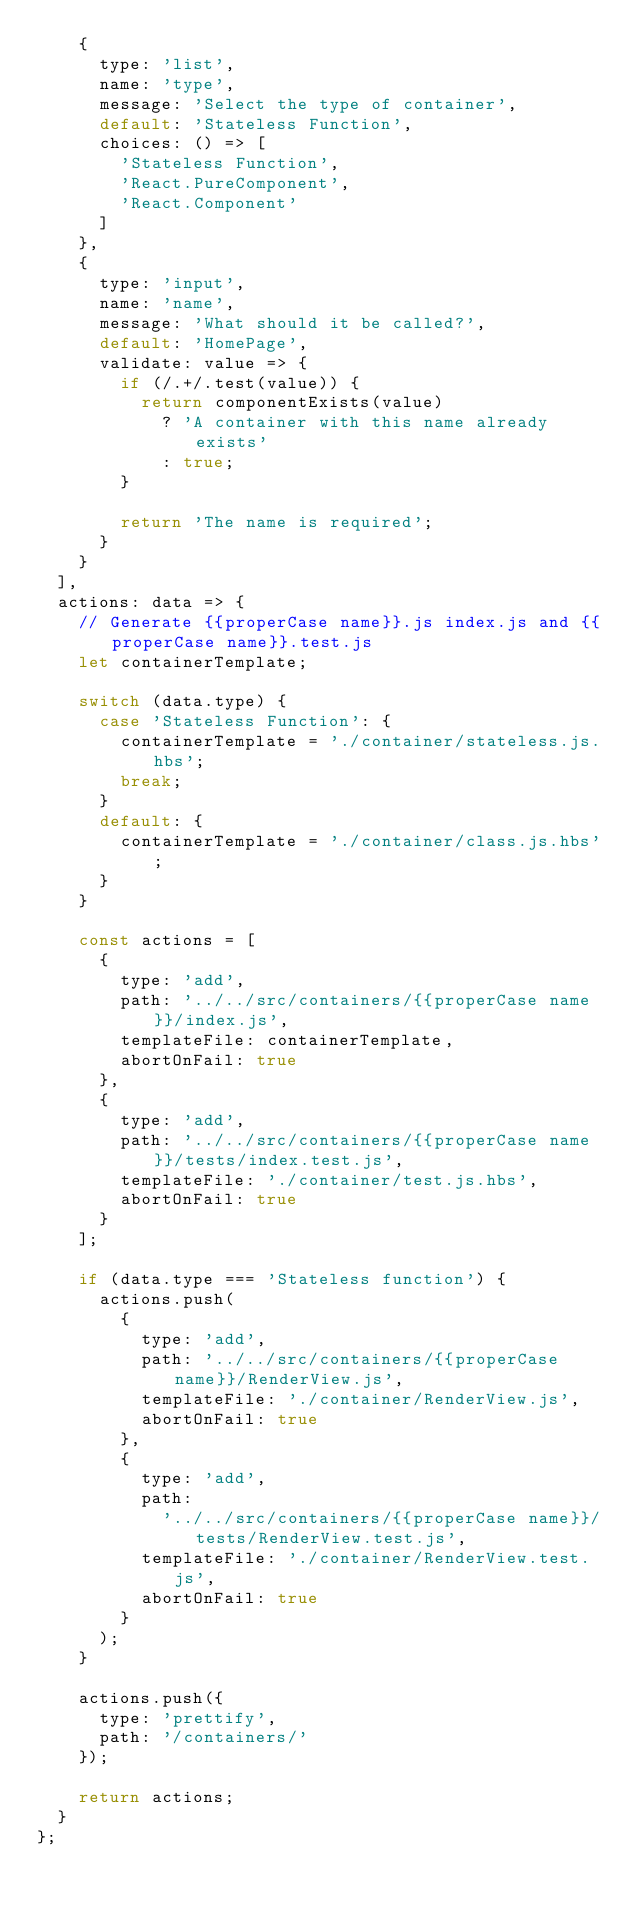Convert code to text. <code><loc_0><loc_0><loc_500><loc_500><_JavaScript_>    {
      type: 'list',
      name: 'type',
      message: 'Select the type of container',
      default: 'Stateless Function',
      choices: () => [
        'Stateless Function',
        'React.PureComponent',
        'React.Component'
      ]
    },
    {
      type: 'input',
      name: 'name',
      message: 'What should it be called?',
      default: 'HomePage',
      validate: value => {
        if (/.+/.test(value)) {
          return componentExists(value)
            ? 'A container with this name already exists'
            : true;
        }

        return 'The name is required';
      }
    }
  ],
  actions: data => {
    // Generate {{properCase name}}.js index.js and {{properCase name}}.test.js
    let containerTemplate;

    switch (data.type) {
      case 'Stateless Function': {
        containerTemplate = './container/stateless.js.hbs';
        break;
      }
      default: {
        containerTemplate = './container/class.js.hbs';
      }
    }

    const actions = [
      {
        type: 'add',
        path: '../../src/containers/{{properCase name}}/index.js',
        templateFile: containerTemplate,
        abortOnFail: true
      },
      {
        type: 'add',
        path: '../../src/containers/{{properCase name}}/tests/index.test.js',
        templateFile: './container/test.js.hbs',
        abortOnFail: true
      }
    ];

    if (data.type === 'Stateless function') {
      actions.push(
        {
          type: 'add',
          path: '../../src/containers/{{properCase name}}/RenderView.js',
          templateFile: './container/RenderView.js',
          abortOnFail: true
        },
        {
          type: 'add',
          path:
            '../../src/containers/{{properCase name}}/tests/RenderView.test.js',
          templateFile: './container/RenderView.test.js',
          abortOnFail: true
        }
      );
    }

    actions.push({
      type: 'prettify',
      path: '/containers/'
    });

    return actions;
  }
};
</code> 